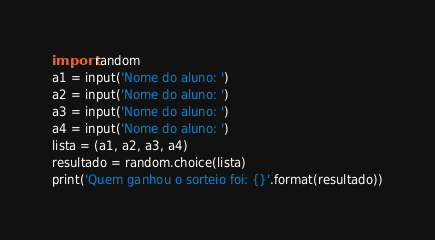<code> <loc_0><loc_0><loc_500><loc_500><_Python_>import random
a1 = input('Nome do aluno: ')
a2 = input('Nome do aluno: ')
a3 = input('Nome do aluno: ')
a4 = input('Nome do aluno: ')
lista = (a1, a2, a3, a4)
resultado = random.choice(lista)
print('Quem ganhou o sorteio foi: {}'.format(resultado))
</code> 